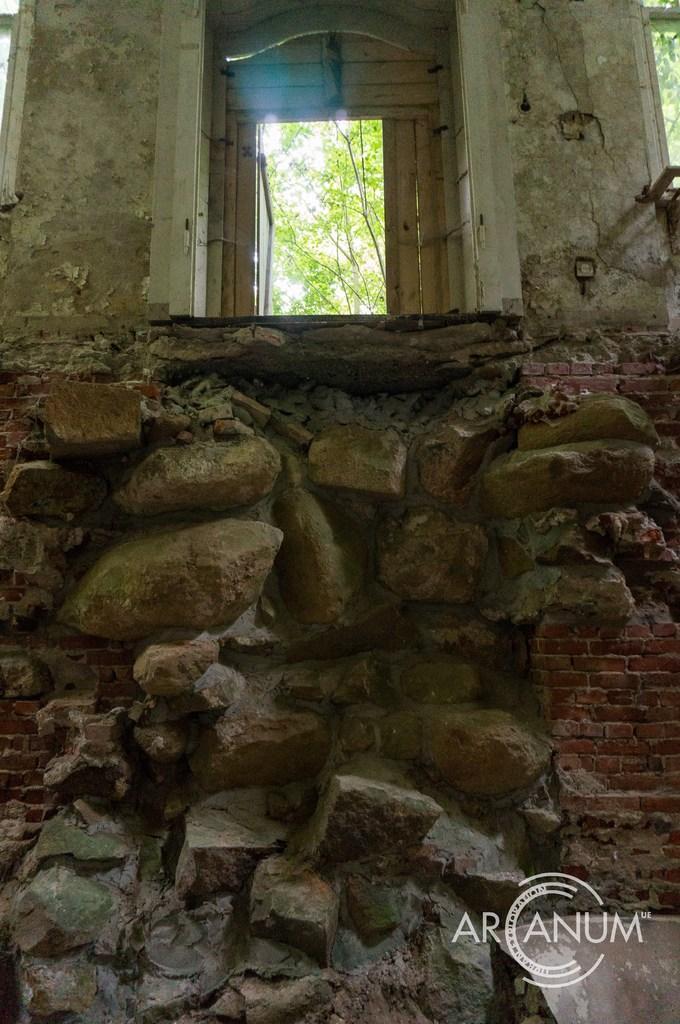Can you describe this image briefly? It is a picture where there are many rocks and above the rocks there is a room it is made up of cement,outside the room there are some trees and sky. 